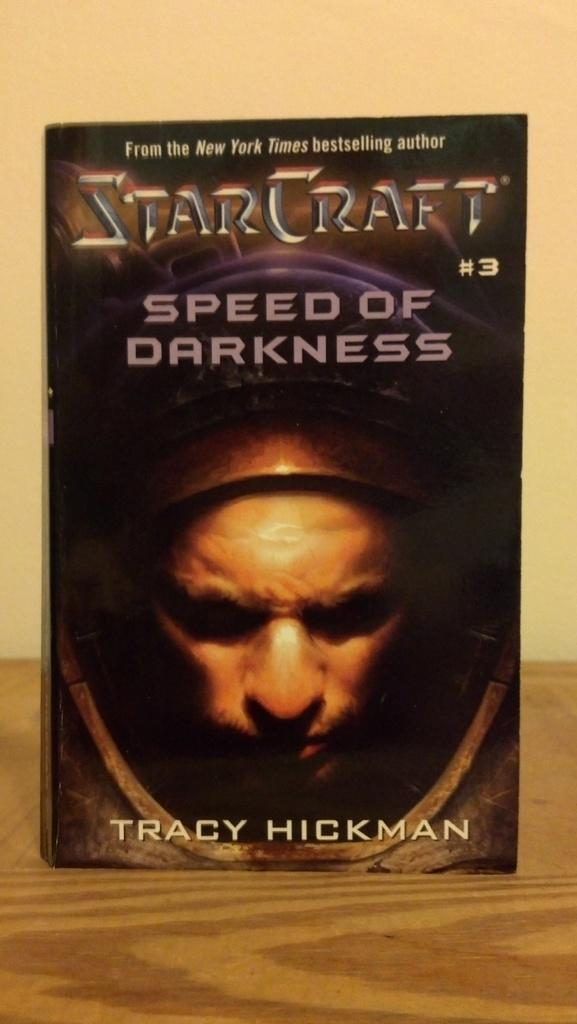What is the main subject of the image? There is a book in the center of the image. Where is the book located? The book is placed on a table. What can be seen in the background of the image? There is a wall in the background of the image. What type of locket is hanging from the roof in the image? There is no locket or roof present in the image; it only features a book on a table with a wall in the background. 